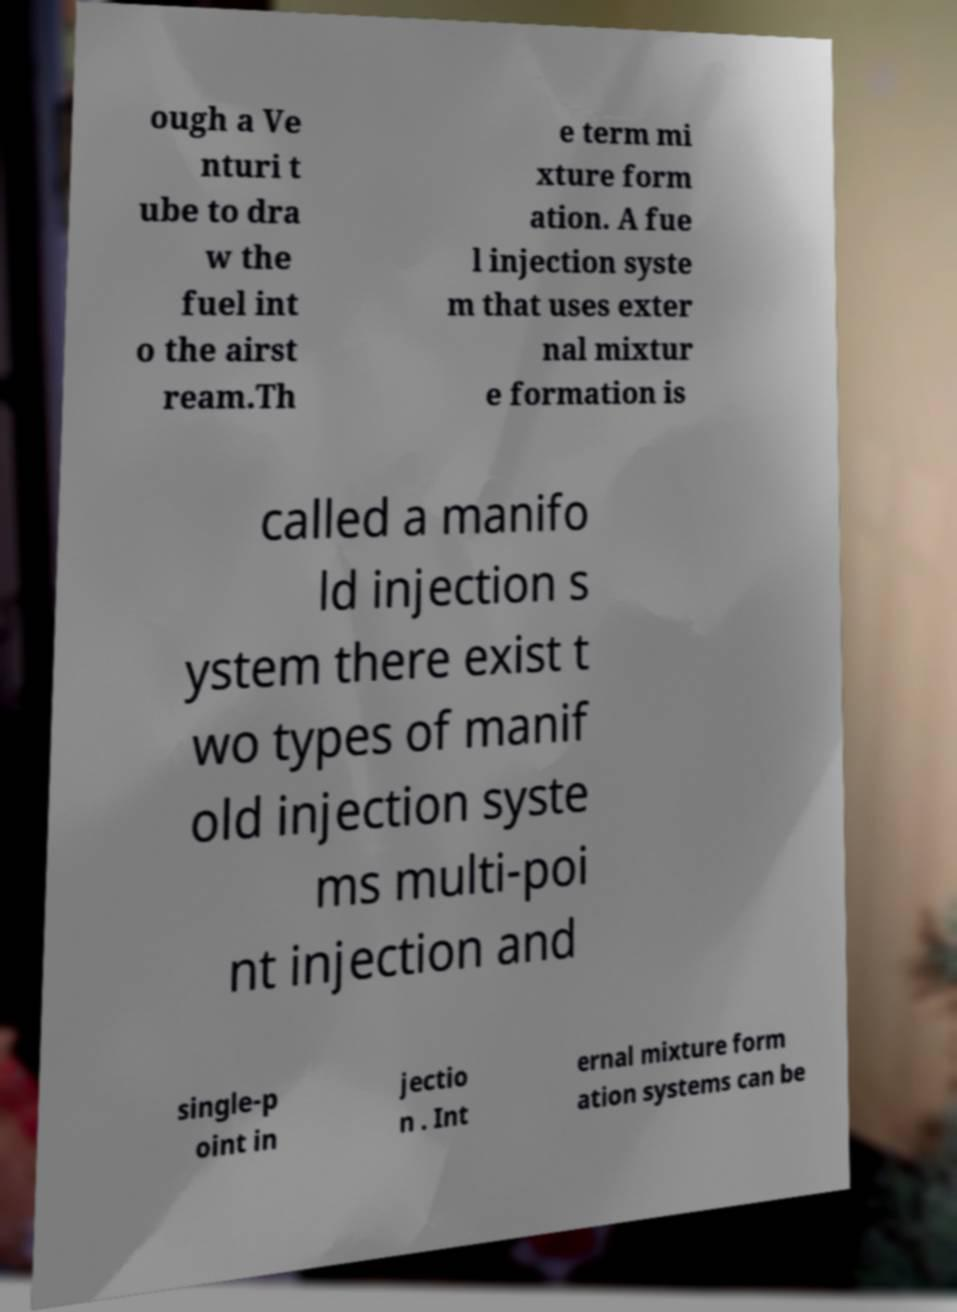Can you accurately transcribe the text from the provided image for me? ough a Ve nturi t ube to dra w the fuel int o the airst ream.Th e term mi xture form ation. A fue l injection syste m that uses exter nal mixtur e formation is called a manifo ld injection s ystem there exist t wo types of manif old injection syste ms multi-poi nt injection and single-p oint in jectio n . Int ernal mixture form ation systems can be 